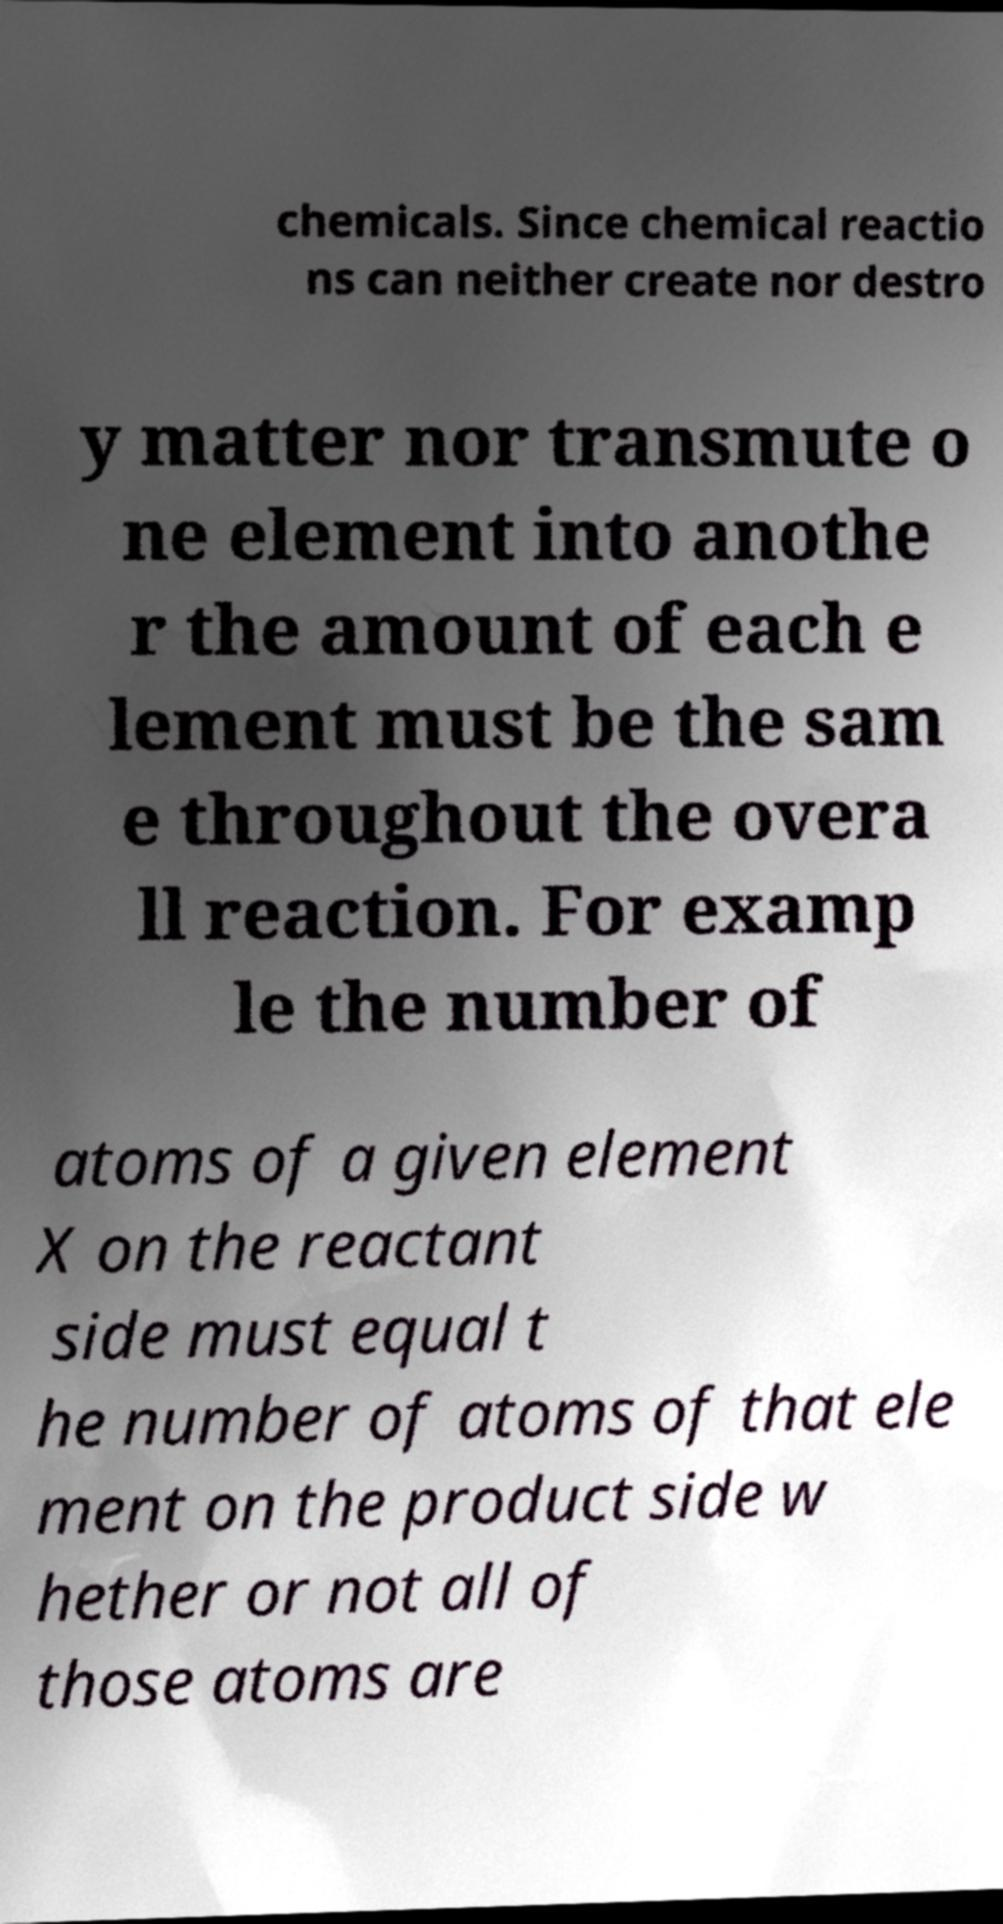What messages or text are displayed in this image? I need them in a readable, typed format. chemicals. Since chemical reactio ns can neither create nor destro y matter nor transmute o ne element into anothe r the amount of each e lement must be the sam e throughout the overa ll reaction. For examp le the number of atoms of a given element X on the reactant side must equal t he number of atoms of that ele ment on the product side w hether or not all of those atoms are 